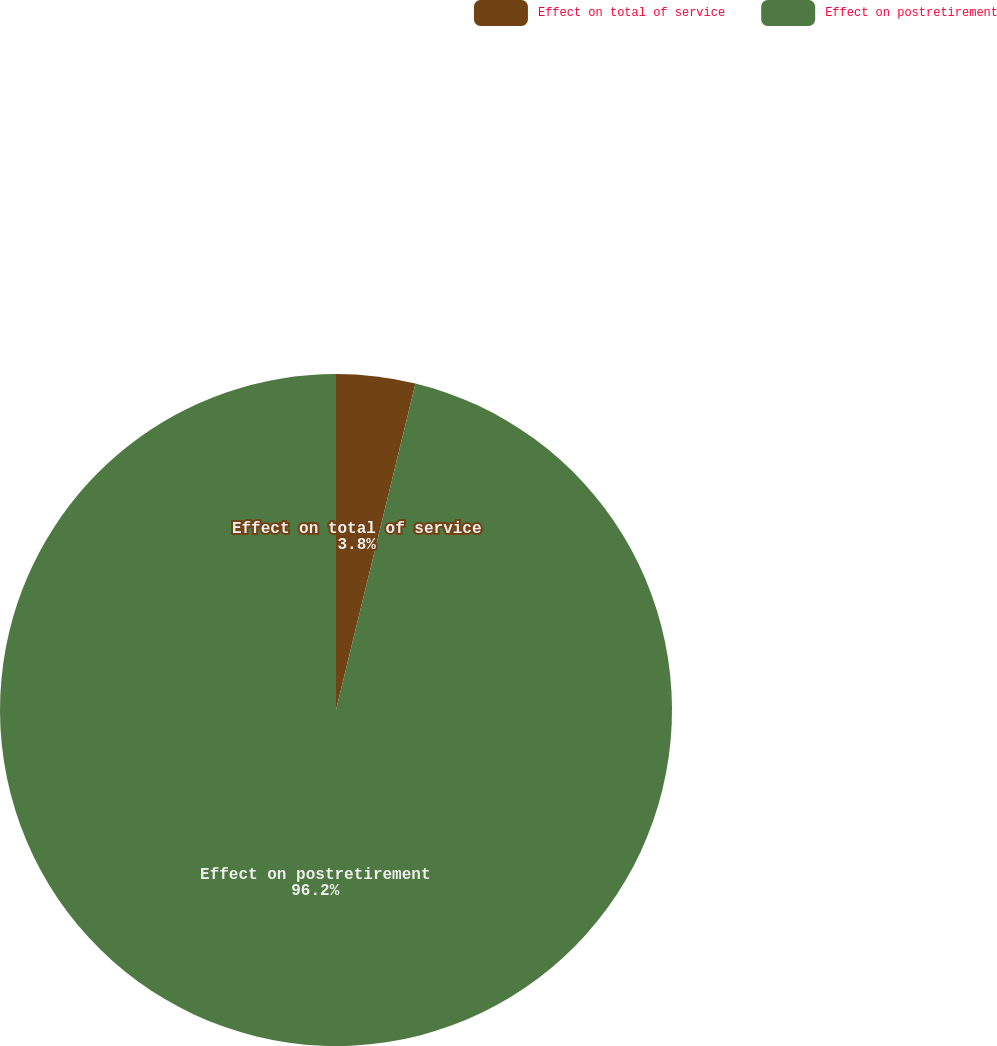Convert chart. <chart><loc_0><loc_0><loc_500><loc_500><pie_chart><fcel>Effect on total of service<fcel>Effect on postretirement<nl><fcel>3.8%<fcel>96.2%<nl></chart> 